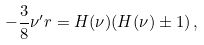Convert formula to latex. <formula><loc_0><loc_0><loc_500><loc_500>- \frac { 3 } { 8 } \nu ^ { \prime } r = H ( \nu ) ( H ( \nu ) \pm 1 ) \, ,</formula> 